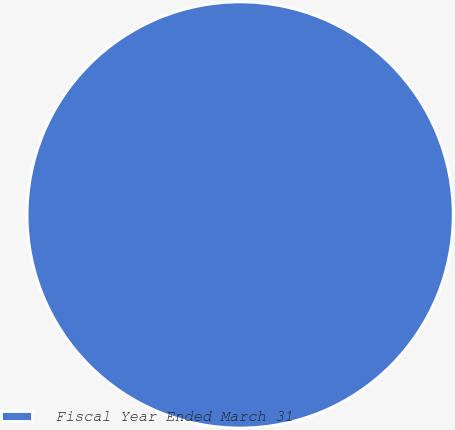<chart> <loc_0><loc_0><loc_500><loc_500><pie_chart><fcel>Fiscal Year Ended March 31<nl><fcel>100.0%<nl></chart> 